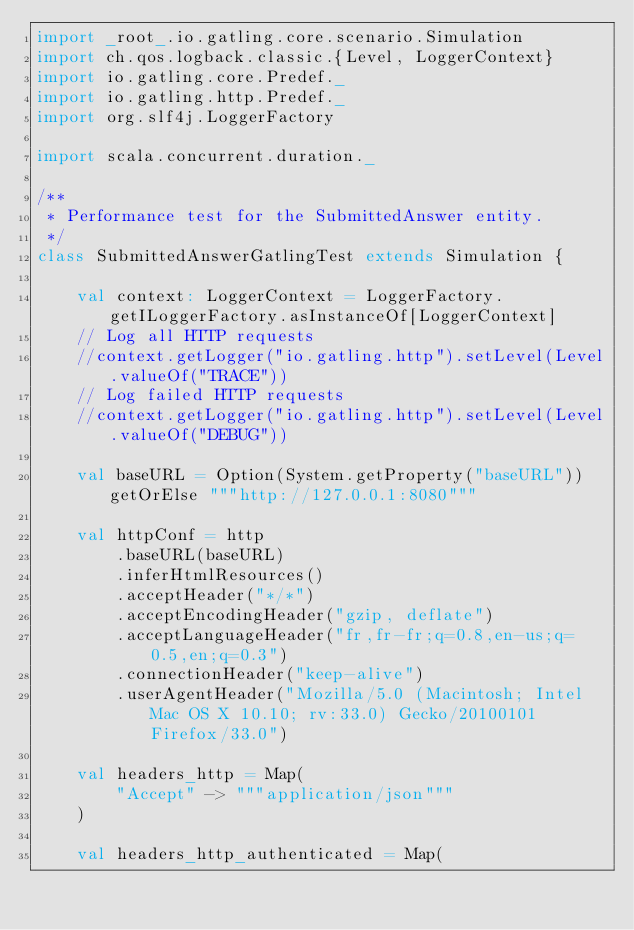Convert code to text. <code><loc_0><loc_0><loc_500><loc_500><_Scala_>import _root_.io.gatling.core.scenario.Simulation
import ch.qos.logback.classic.{Level, LoggerContext}
import io.gatling.core.Predef._
import io.gatling.http.Predef._
import org.slf4j.LoggerFactory

import scala.concurrent.duration._

/**
 * Performance test for the SubmittedAnswer entity.
 */
class SubmittedAnswerGatlingTest extends Simulation {

    val context: LoggerContext = LoggerFactory.getILoggerFactory.asInstanceOf[LoggerContext]
    // Log all HTTP requests
    //context.getLogger("io.gatling.http").setLevel(Level.valueOf("TRACE"))
    // Log failed HTTP requests
    //context.getLogger("io.gatling.http").setLevel(Level.valueOf("DEBUG"))

    val baseURL = Option(System.getProperty("baseURL")) getOrElse """http://127.0.0.1:8080"""

    val httpConf = http
        .baseURL(baseURL)
        .inferHtmlResources()
        .acceptHeader("*/*")
        .acceptEncodingHeader("gzip, deflate")
        .acceptLanguageHeader("fr,fr-fr;q=0.8,en-us;q=0.5,en;q=0.3")
        .connectionHeader("keep-alive")
        .userAgentHeader("Mozilla/5.0 (Macintosh; Intel Mac OS X 10.10; rv:33.0) Gecko/20100101 Firefox/33.0")

    val headers_http = Map(
        "Accept" -> """application/json"""
    )

    val headers_http_authenticated = Map(</code> 